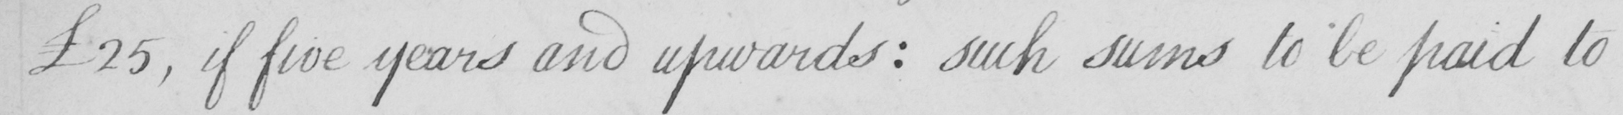What does this handwritten line say? £25 , if five years and upwards :  such sums to be paid to 